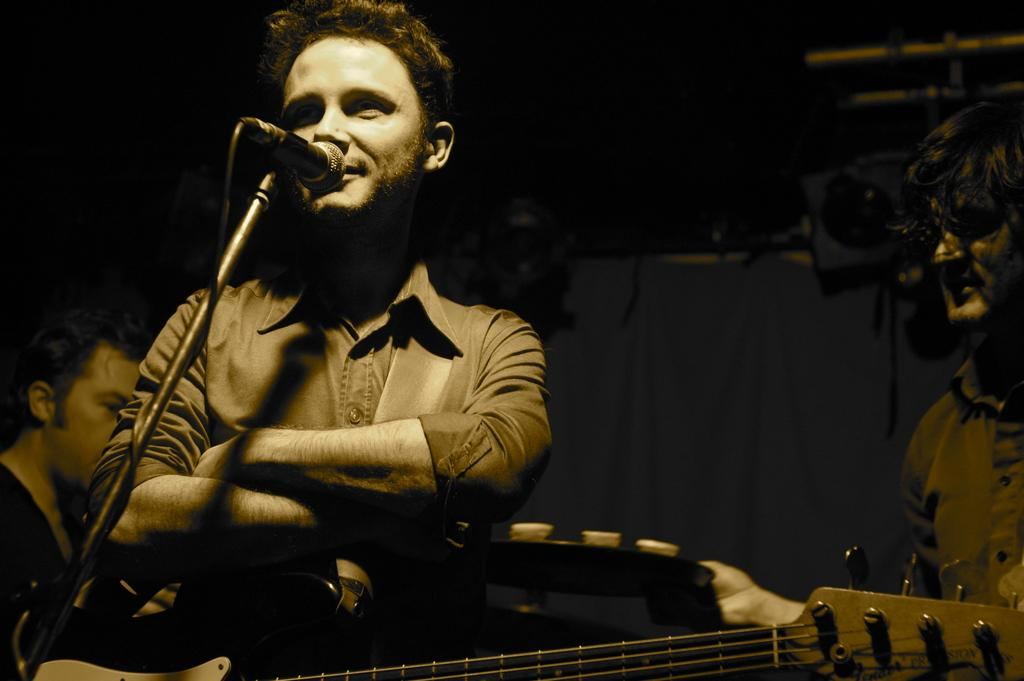What is the man in the image doing? The man is singing in the image. What instrument is visible in the image? There is a guitar in the image. How many people are present in the image? There are two people in the image. What are the positions of the people in the image? One person is standing on the right side of the image, and the other person is sitting on the left side of the image. What type of underwear is the man wearing in the image? There is no information about the man's underwear in the image, and it is not visible. Can you describe the curtain in the image? There is no curtain present in the image. 